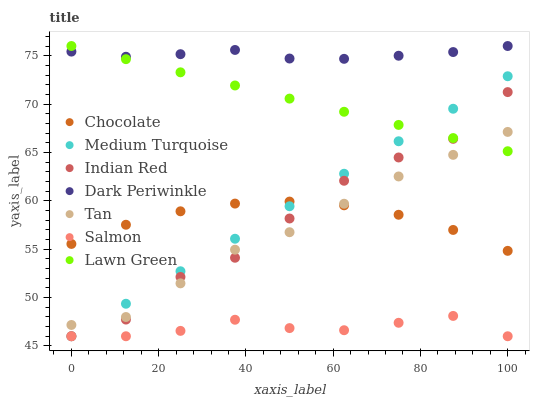Does Salmon have the minimum area under the curve?
Answer yes or no. Yes. Does Dark Periwinkle have the maximum area under the curve?
Answer yes or no. Yes. Does Medium Turquoise have the minimum area under the curve?
Answer yes or no. No. Does Medium Turquoise have the maximum area under the curve?
Answer yes or no. No. Is Lawn Green the smoothest?
Answer yes or no. Yes. Is Indian Red the roughest?
Answer yes or no. Yes. Is Medium Turquoise the smoothest?
Answer yes or no. No. Is Medium Turquoise the roughest?
Answer yes or no. No. Does Medium Turquoise have the lowest value?
Answer yes or no. Yes. Does Chocolate have the lowest value?
Answer yes or no. No. Does Dark Periwinkle have the highest value?
Answer yes or no. Yes. Does Medium Turquoise have the highest value?
Answer yes or no. No. Is Salmon less than Dark Periwinkle?
Answer yes or no. Yes. Is Lawn Green greater than Salmon?
Answer yes or no. Yes. Does Dark Periwinkle intersect Lawn Green?
Answer yes or no. Yes. Is Dark Periwinkle less than Lawn Green?
Answer yes or no. No. Is Dark Periwinkle greater than Lawn Green?
Answer yes or no. No. Does Salmon intersect Dark Periwinkle?
Answer yes or no. No. 